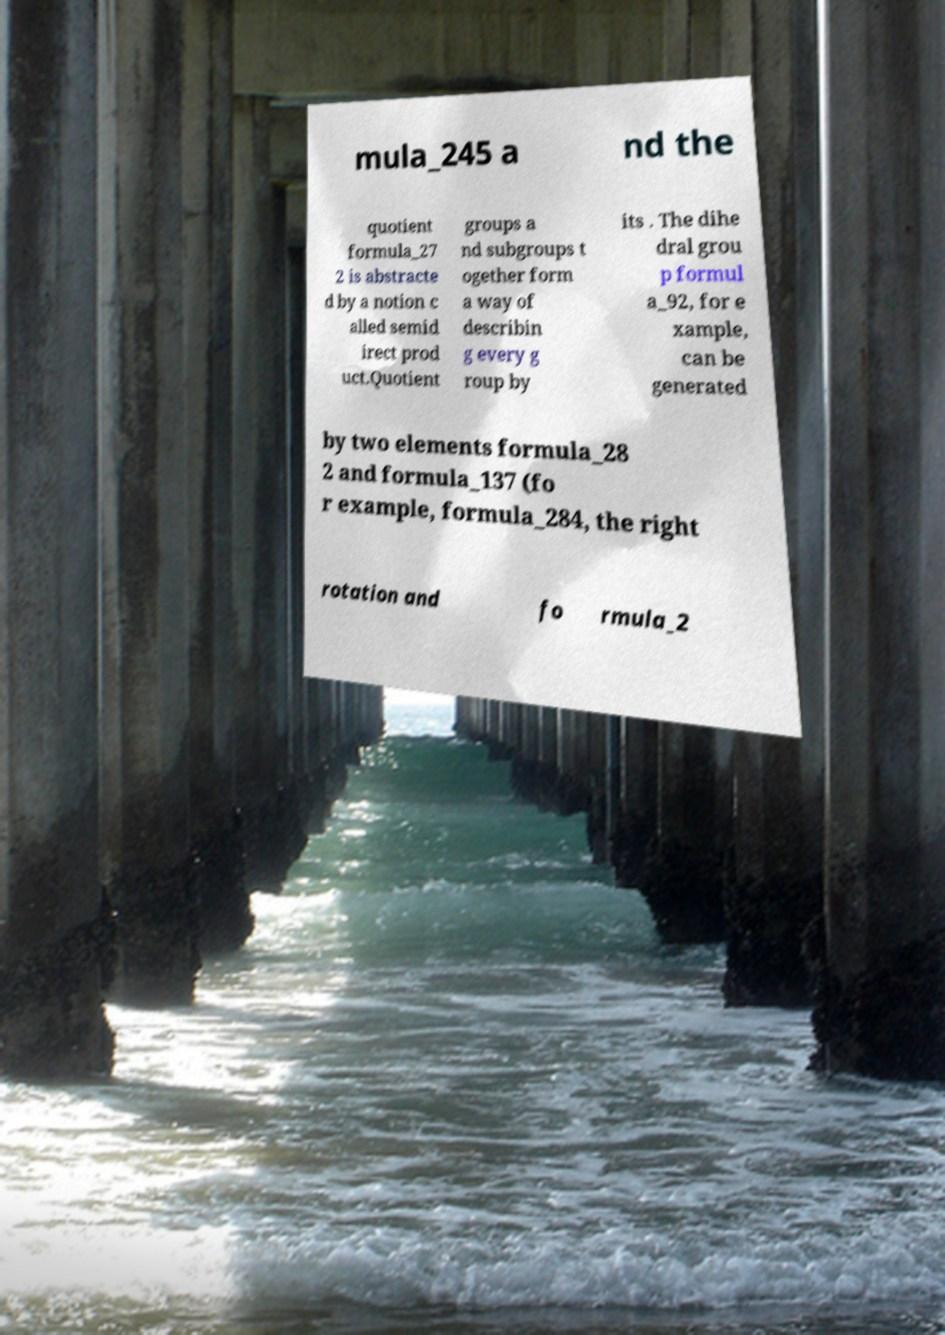Could you assist in decoding the text presented in this image and type it out clearly? mula_245 a nd the quotient formula_27 2 is abstracte d by a notion c alled semid irect prod uct.Quotient groups a nd subgroups t ogether form a way of describin g every g roup by its . The dihe dral grou p formul a_92, for e xample, can be generated by two elements formula_28 2 and formula_137 (fo r example, formula_284, the right rotation and fo rmula_2 